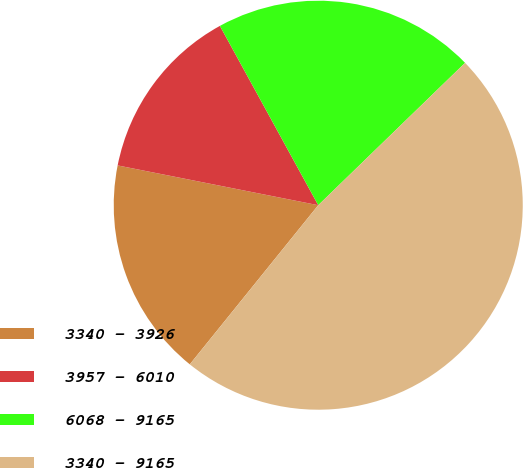Convert chart. <chart><loc_0><loc_0><loc_500><loc_500><pie_chart><fcel>3340 - 3926<fcel>3957 - 6010<fcel>6068 - 9165<fcel>3340 - 9165<nl><fcel>17.31%<fcel>13.9%<fcel>20.73%<fcel>48.06%<nl></chart> 